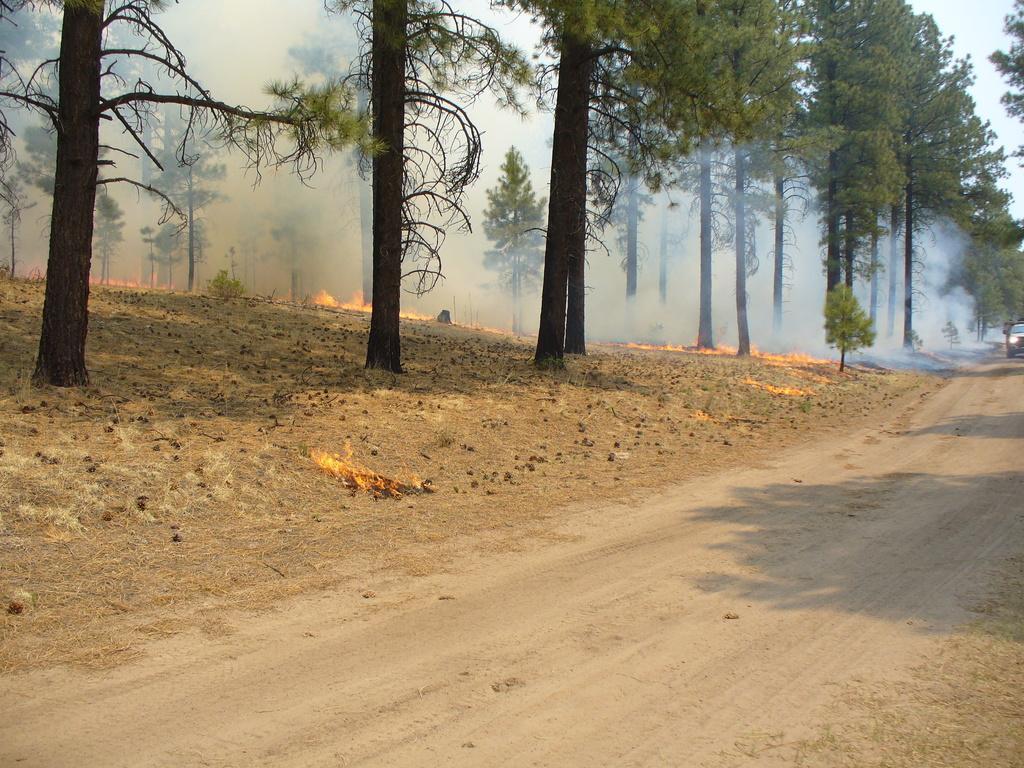Could you give a brief overview of what you see in this image? In this image we can see vehicle on road, trees, fire and smoke. 